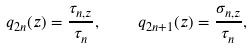Convert formula to latex. <formula><loc_0><loc_0><loc_500><loc_500>q _ { 2 n } ( z ) = \frac { \tau _ { n , z } } { \tau _ { n } } , \quad q _ { 2 n + 1 } ( z ) = \frac { \sigma _ { n , z } } { \tau _ { n } } ,</formula> 